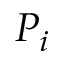<formula> <loc_0><loc_0><loc_500><loc_500>P _ { i }</formula> 